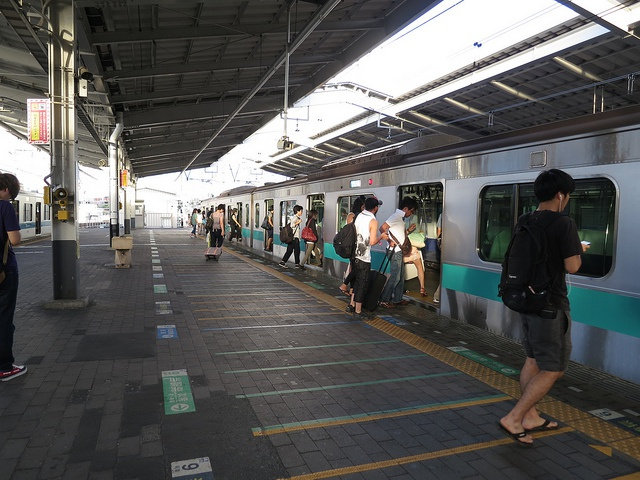Describe the objects in this image and their specific colors. I can see train in black, gray, darkgray, and teal tones, people in black, brown, and maroon tones, backpack in black, gray, and teal tones, people in black, gray, and maroon tones, and people in black, white, and gray tones in this image. 